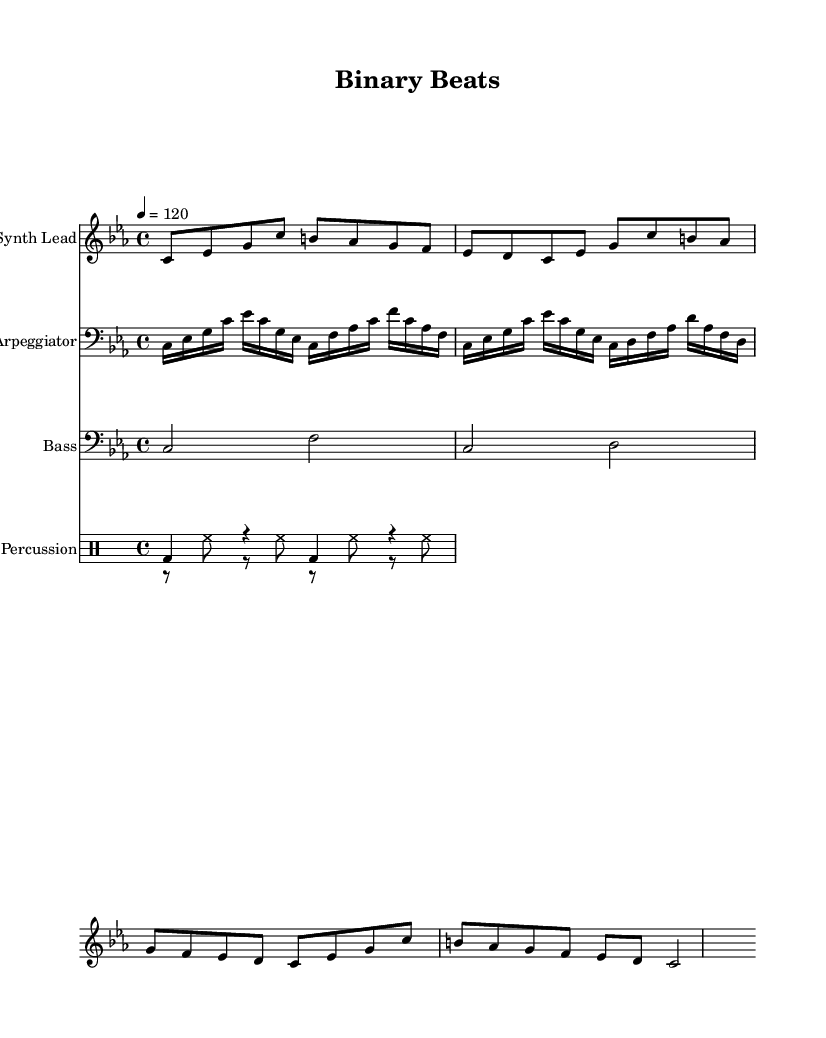What is the key signature of this music? The key signature is C minor, which has three flats (B flat, E flat, and A flat). This can be identified from the initial key indication at the beginning of the score.
Answer: C minor What is the time signature of this music? The time signature is 4/4, indicated after the key signature. This means there are four beats in each measure, and the quarter note gets one beat.
Answer: 4/4 What is the tempo marking of the piece? The tempo marking is 120 beats per minute, shown as "4 = 120". This gives performers the speed at which to play the music.
Answer: 120 How many measures are in the "Synth Lead" section? The "Synth Lead" section consists of four measures, as indicated by the grouping of musical notation between the bar lines.
Answer: 4 What type of percussion instruments are used in the rhythm section? The rhythm section features a bass drum and hi-hat, as indicated by the respective notations written for each instrument in the percussion staff.
Answer: Bass drum and hi-hat Which instrument plays the arpeggiated part? The arpeggiated part is played by the instrument labeled "Arpeggiator", which is specified in the score along with its musical notation.
Answer: Arpeggiator What is the highest note in the "Bass" staff? The highest note in the "Bass" staff is F. This can be determined by reviewing the specific notes written in that staff.
Answer: F 